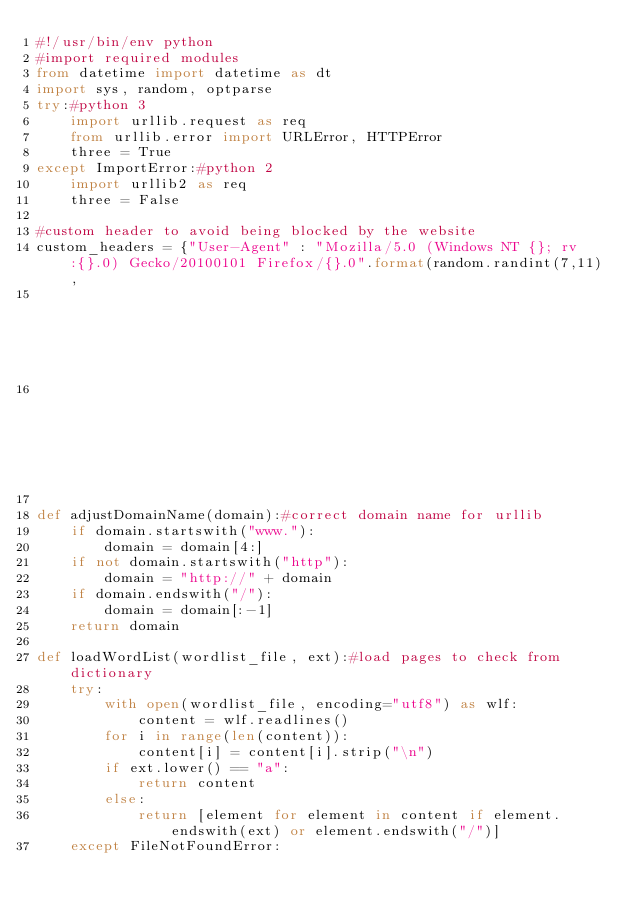Convert code to text. <code><loc_0><loc_0><loc_500><loc_500><_Python_>#!/usr/bin/env python
#import required modules
from datetime import datetime as dt
import sys, random, optparse
try:#python 3
    import urllib.request as req
    from urllib.error import URLError, HTTPError
    three = True
except ImportError:#python 2
    import urllib2 as req
    three = False

#custom header to avoid being blocked by the website
custom_headers = {"User-Agent" : "Mozilla/5.0 (Windows NT {}; rv:{}.0) Gecko/20100101 Firefox/{}.0".format(random.randint(7,11),
                                                                                                           random.randint(40,50),
                                                                                                           random.randint(35,50))}

def adjustDomainName(domain):#correct domain name for urllib
    if domain.startswith("www."):
        domain = domain[4:]
    if not domain.startswith("http"):
        domain = "http://" + domain
    if domain.endswith("/"):
        domain = domain[:-1]
    return domain

def loadWordList(wordlist_file, ext):#load pages to check from dictionary
    try:
        with open(wordlist_file, encoding="utf8") as wlf:
            content = wlf.readlines()
        for i in range(len(content)):
            content[i] = content[i].strip("\n")
        if ext.lower() == "a":
            return content
        else:
            return [element for element in content if element.endswith(ext) or element.endswith("/")]
    except FileNotFoundError:</code> 